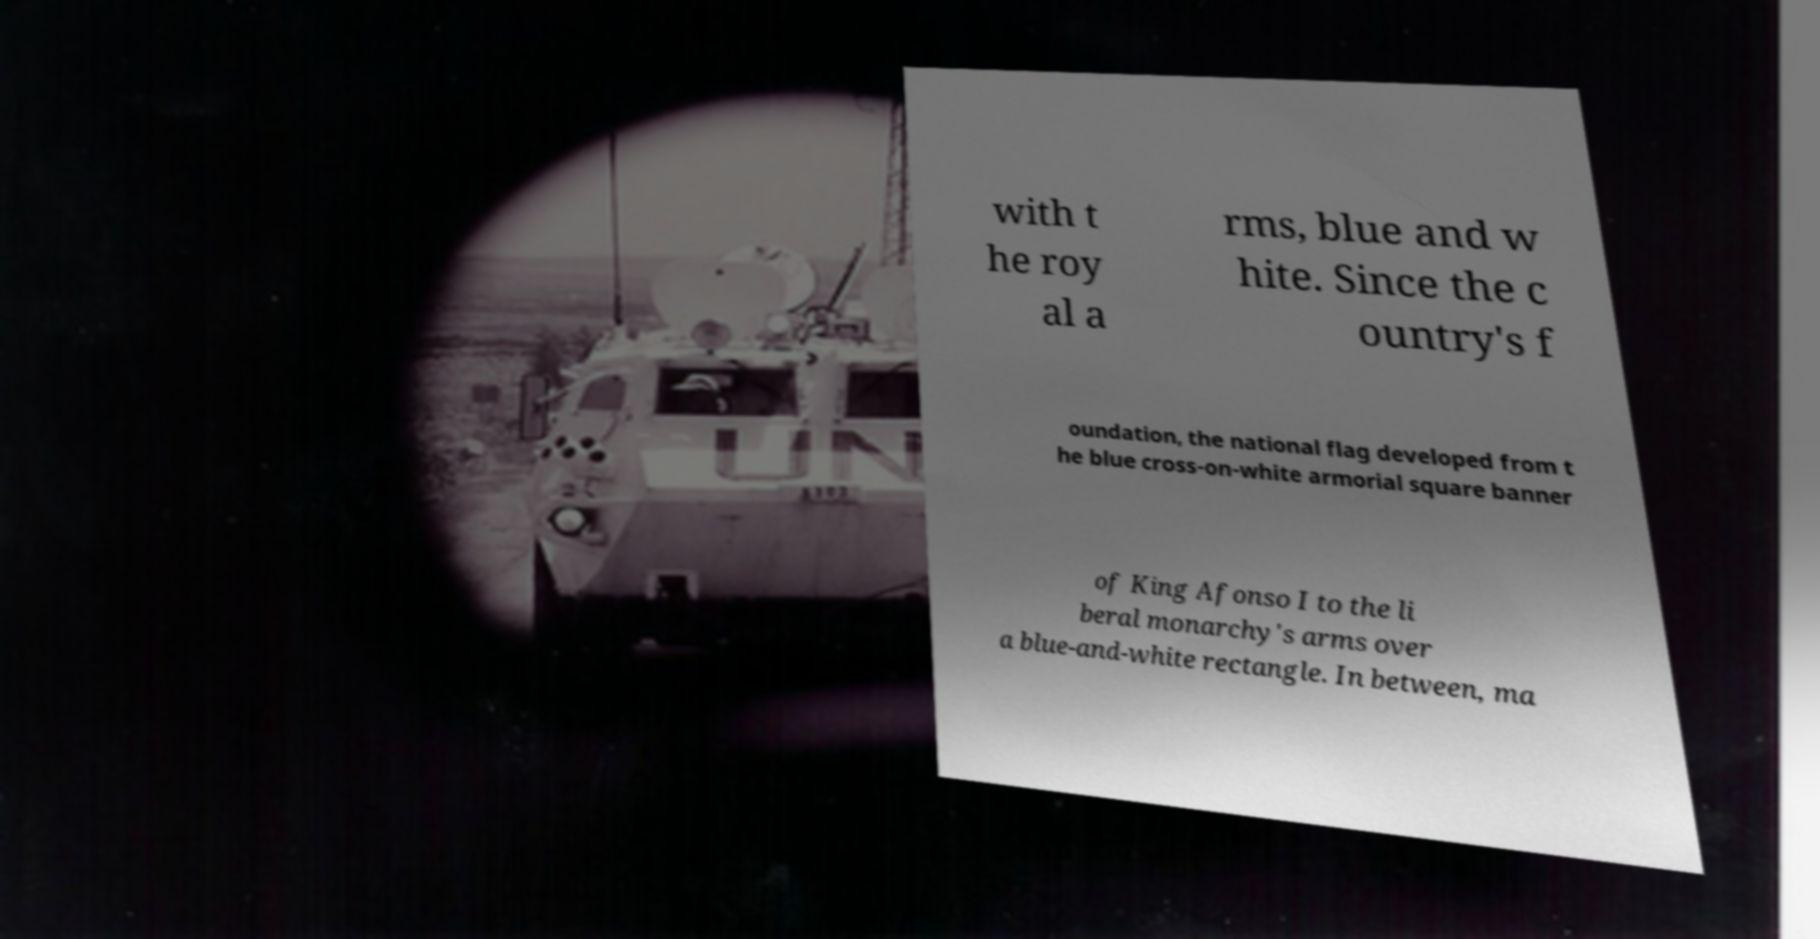Could you assist in decoding the text presented in this image and type it out clearly? with t he roy al a rms, blue and w hite. Since the c ountry's f oundation, the national flag developed from t he blue cross-on-white armorial square banner of King Afonso I to the li beral monarchy's arms over a blue-and-white rectangle. In between, ma 